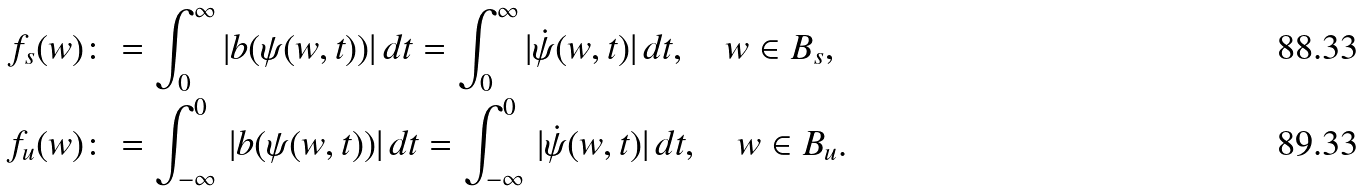<formula> <loc_0><loc_0><loc_500><loc_500>f _ { s } ( w ) & \colon = \int _ { 0 } ^ { \infty } | b ( \psi ( w , t ) ) | \, d t = \int _ { 0 } ^ { \infty } | \dot { \psi } ( w , t ) | \, d t , \quad w \in B _ { s } , \\ f _ { u } ( w ) & \colon = \int _ { - \infty } ^ { 0 } \, | b ( \psi ( w , t ) ) | \, d t = \int _ { - \infty } ^ { 0 } \, | \dot { \psi } ( w , t ) | \, d t , \quad w \in B _ { u } .</formula> 